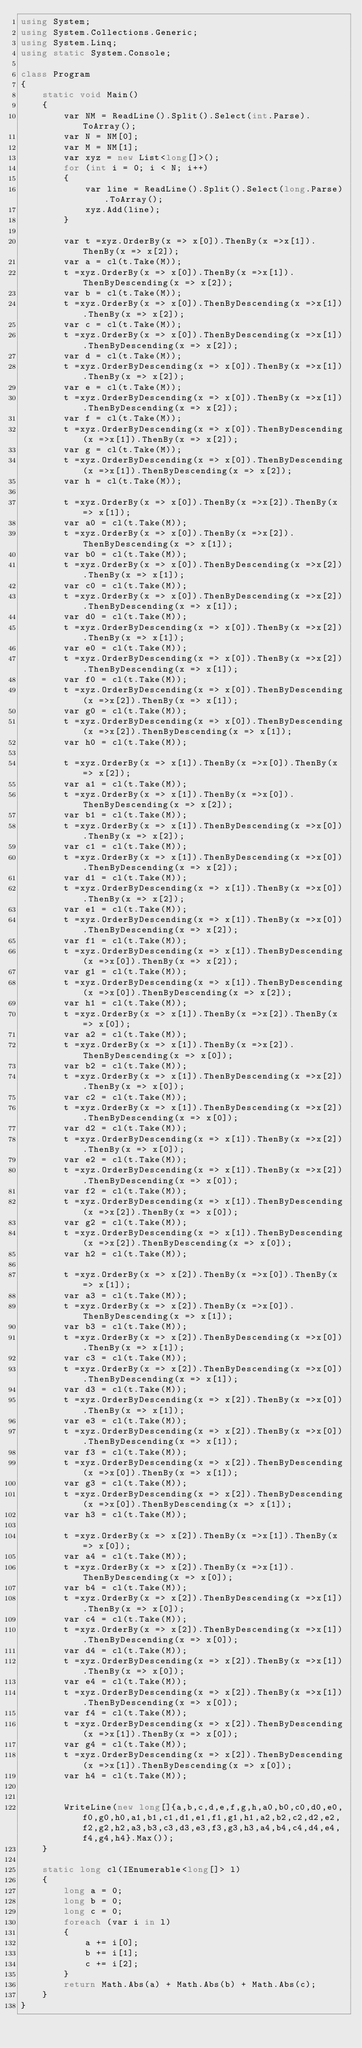Convert code to text. <code><loc_0><loc_0><loc_500><loc_500><_C#_>using System;
using System.Collections.Generic;
using System.Linq;
using static System.Console;

class Program
{
    static void Main()
    {
        var NM = ReadLine().Split().Select(int.Parse).ToArray();
        var N = NM[0];
        var M = NM[1];
        var xyz = new List<long[]>();
        for (int i = 0; i < N; i++)
        {
            var line = ReadLine().Split().Select(long.Parse).ToArray();
            xyz.Add(line);
        }

        var t =xyz.OrderBy(x => x[0]).ThenBy(x =>x[1]).ThenBy(x => x[2]);
        var a = cl(t.Take(M));
        t =xyz.OrderBy(x => x[0]).ThenBy(x =>x[1]).ThenByDescending(x => x[2]);
        var b = cl(t.Take(M));
        t =xyz.OrderBy(x => x[0]).ThenByDescending(x =>x[1]).ThenBy(x => x[2]);
        var c = cl(t.Take(M));
        t =xyz.OrderBy(x => x[0]).ThenByDescending(x =>x[1]).ThenByDescending(x => x[2]);
        var d = cl(t.Take(M));
        t =xyz.OrderByDescending(x => x[0]).ThenBy(x =>x[1]).ThenBy(x => x[2]);
        var e = cl(t.Take(M));
        t =xyz.OrderByDescending(x => x[0]).ThenBy(x =>x[1]).ThenByDescending(x => x[2]);
        var f = cl(t.Take(M));
        t =xyz.OrderByDescending(x => x[0]).ThenByDescending(x =>x[1]).ThenBy(x => x[2]);
        var g = cl(t.Take(M));
        t =xyz.OrderByDescending(x => x[0]).ThenByDescending(x =>x[1]).ThenByDescending(x => x[2]);
        var h = cl(t.Take(M));

        t =xyz.OrderBy(x => x[0]).ThenBy(x =>x[2]).ThenBy(x => x[1]);
        var a0 = cl(t.Take(M));
        t =xyz.OrderBy(x => x[0]).ThenBy(x =>x[2]).ThenByDescending(x => x[1]);
        var b0 = cl(t.Take(M));
        t =xyz.OrderBy(x => x[0]).ThenByDescending(x =>x[2]).ThenBy(x => x[1]);
        var c0 = cl(t.Take(M));
        t =xyz.OrderBy(x => x[0]).ThenByDescending(x =>x[2]).ThenByDescending(x => x[1]);
        var d0 = cl(t.Take(M));
        t =xyz.OrderByDescending(x => x[0]).ThenBy(x =>x[2]).ThenBy(x => x[1]);
        var e0 = cl(t.Take(M));
        t =xyz.OrderByDescending(x => x[0]).ThenBy(x =>x[2]).ThenByDescending(x => x[1]);
        var f0 = cl(t.Take(M));
        t =xyz.OrderByDescending(x => x[0]).ThenByDescending(x =>x[2]).ThenBy(x => x[1]);
        var g0 = cl(t.Take(M));
        t =xyz.OrderByDescending(x => x[0]).ThenByDescending(x =>x[2]).ThenByDescending(x => x[1]);
        var h0 = cl(t.Take(M));

        t =xyz.OrderBy(x => x[1]).ThenBy(x =>x[0]).ThenBy(x => x[2]);
        var a1 = cl(t.Take(M));
        t =xyz.OrderBy(x => x[1]).ThenBy(x =>x[0]).ThenByDescending(x => x[2]);
        var b1 = cl(t.Take(M));
        t =xyz.OrderBy(x => x[1]).ThenByDescending(x =>x[0]).ThenBy(x => x[2]);
        var c1 = cl(t.Take(M));
        t =xyz.OrderBy(x => x[1]).ThenByDescending(x =>x[0]).ThenByDescending(x => x[2]);
        var d1 = cl(t.Take(M));
        t =xyz.OrderByDescending(x => x[1]).ThenBy(x =>x[0]).ThenBy(x => x[2]);
        var e1 = cl(t.Take(M));
        t =xyz.OrderByDescending(x => x[1]).ThenBy(x =>x[0]).ThenByDescending(x => x[2]);
        var f1 = cl(t.Take(M));
        t =xyz.OrderByDescending(x => x[1]).ThenByDescending(x =>x[0]).ThenBy(x => x[2]);
        var g1 = cl(t.Take(M));
        t =xyz.OrderByDescending(x => x[1]).ThenByDescending(x =>x[0]).ThenByDescending(x => x[2]);
        var h1 = cl(t.Take(M));
        t =xyz.OrderBy(x => x[1]).ThenBy(x =>x[2]).ThenBy(x => x[0]);
        var a2 = cl(t.Take(M));
        t =xyz.OrderBy(x => x[1]).ThenBy(x =>x[2]).ThenByDescending(x => x[0]);
        var b2 = cl(t.Take(M));
        t =xyz.OrderBy(x => x[1]).ThenByDescending(x =>x[2]).ThenBy(x => x[0]);
        var c2 = cl(t.Take(M));
        t =xyz.OrderBy(x => x[1]).ThenByDescending(x =>x[2]).ThenByDescending(x => x[0]);
        var d2 = cl(t.Take(M));
        t =xyz.OrderByDescending(x => x[1]).ThenBy(x =>x[2]).ThenBy(x => x[0]);
        var e2 = cl(t.Take(M));
        t =xyz.OrderByDescending(x => x[1]).ThenBy(x =>x[2]).ThenByDescending(x => x[0]);
        var f2 = cl(t.Take(M));
        t =xyz.OrderByDescending(x => x[1]).ThenByDescending(x =>x[2]).ThenBy(x => x[0]);
        var g2 = cl(t.Take(M));
        t =xyz.OrderByDescending(x => x[1]).ThenByDescending(x =>x[2]).ThenByDescending(x => x[0]);
        var h2 = cl(t.Take(M));

        t =xyz.OrderBy(x => x[2]).ThenBy(x =>x[0]).ThenBy(x => x[1]);
        var a3 = cl(t.Take(M));
        t =xyz.OrderBy(x => x[2]).ThenBy(x =>x[0]).ThenByDescending(x => x[1]);
        var b3 = cl(t.Take(M));
        t =xyz.OrderBy(x => x[2]).ThenByDescending(x =>x[0]).ThenBy(x => x[1]);
        var c3 = cl(t.Take(M));
        t =xyz.OrderBy(x => x[2]).ThenByDescending(x =>x[0]).ThenByDescending(x => x[1]);
        var d3 = cl(t.Take(M));
        t =xyz.OrderByDescending(x => x[2]).ThenBy(x =>x[0]).ThenBy(x => x[1]);
        var e3 = cl(t.Take(M));
        t =xyz.OrderByDescending(x => x[2]).ThenBy(x =>x[0]).ThenByDescending(x => x[1]);
        var f3 = cl(t.Take(M));
        t =xyz.OrderByDescending(x => x[2]).ThenByDescending(x =>x[0]).ThenBy(x => x[1]);
        var g3 = cl(t.Take(M));
        t =xyz.OrderByDescending(x => x[2]).ThenByDescending(x =>x[0]).ThenByDescending(x => x[1]);
        var h3 = cl(t.Take(M));

        t =xyz.OrderBy(x => x[2]).ThenBy(x =>x[1]).ThenBy(x => x[0]);
        var a4 = cl(t.Take(M));
        t =xyz.OrderBy(x => x[2]).ThenBy(x =>x[1]).ThenByDescending(x => x[0]);
        var b4 = cl(t.Take(M));
        t =xyz.OrderBy(x => x[2]).ThenByDescending(x =>x[1]).ThenBy(x => x[0]);
        var c4 = cl(t.Take(M));
        t =xyz.OrderBy(x => x[2]).ThenByDescending(x =>x[1]).ThenByDescending(x => x[0]);
        var d4 = cl(t.Take(M));
        t =xyz.OrderByDescending(x => x[2]).ThenBy(x =>x[1]).ThenBy(x => x[0]);
        var e4 = cl(t.Take(M));
        t =xyz.OrderByDescending(x => x[2]).ThenBy(x =>x[1]).ThenByDescending(x => x[0]);
        var f4 = cl(t.Take(M));
        t =xyz.OrderByDescending(x => x[2]).ThenByDescending(x =>x[1]).ThenBy(x => x[0]);
        var g4 = cl(t.Take(M));
        t =xyz.OrderByDescending(x => x[2]).ThenByDescending(x =>x[1]).ThenByDescending(x => x[0]);
        var h4 = cl(t.Take(M));


        WriteLine(new long[]{a,b,c,d,e,f,g,h,a0,b0,c0,d0,e0,f0,g0,h0,a1,b1,c1,d1,e1,f1,g1,h1,a2,b2,c2,d2,e2,f2,g2,h2,a3,b3,c3,d3,e3,f3,g3,h3,a4,b4,c4,d4,e4,f4,g4,h4}.Max());
    }

    static long cl(IEnumerable<long[]> l)
    {
        long a = 0;
        long b = 0;
        long c = 0;
        foreach (var i in l)
        {
            a += i[0];
            b += i[1];
            c += i[2];
        }
        return Math.Abs(a) + Math.Abs(b) + Math.Abs(c);
    }
}</code> 